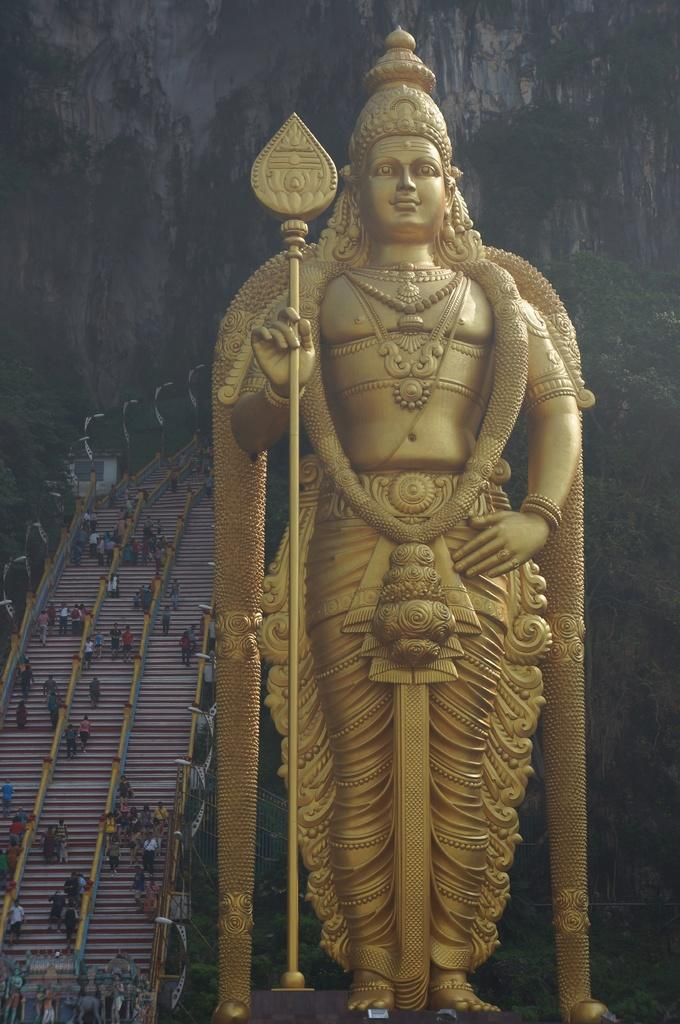What is the main subject in the image? There is a statue in the image. What can be seen in the background of the image? There are people on the stairs and trees in the background of the image. Are there any other objects or features in the image? Yes, there is a rock in the image. What type of ship can be seen sailing in the background of the image? There is no ship present in the image; it only features a statue, people on the stairs, trees, and a rock. What nut is being used to hold the statue in place? The statue is not held in place by a nut, as it is a solid structure. 